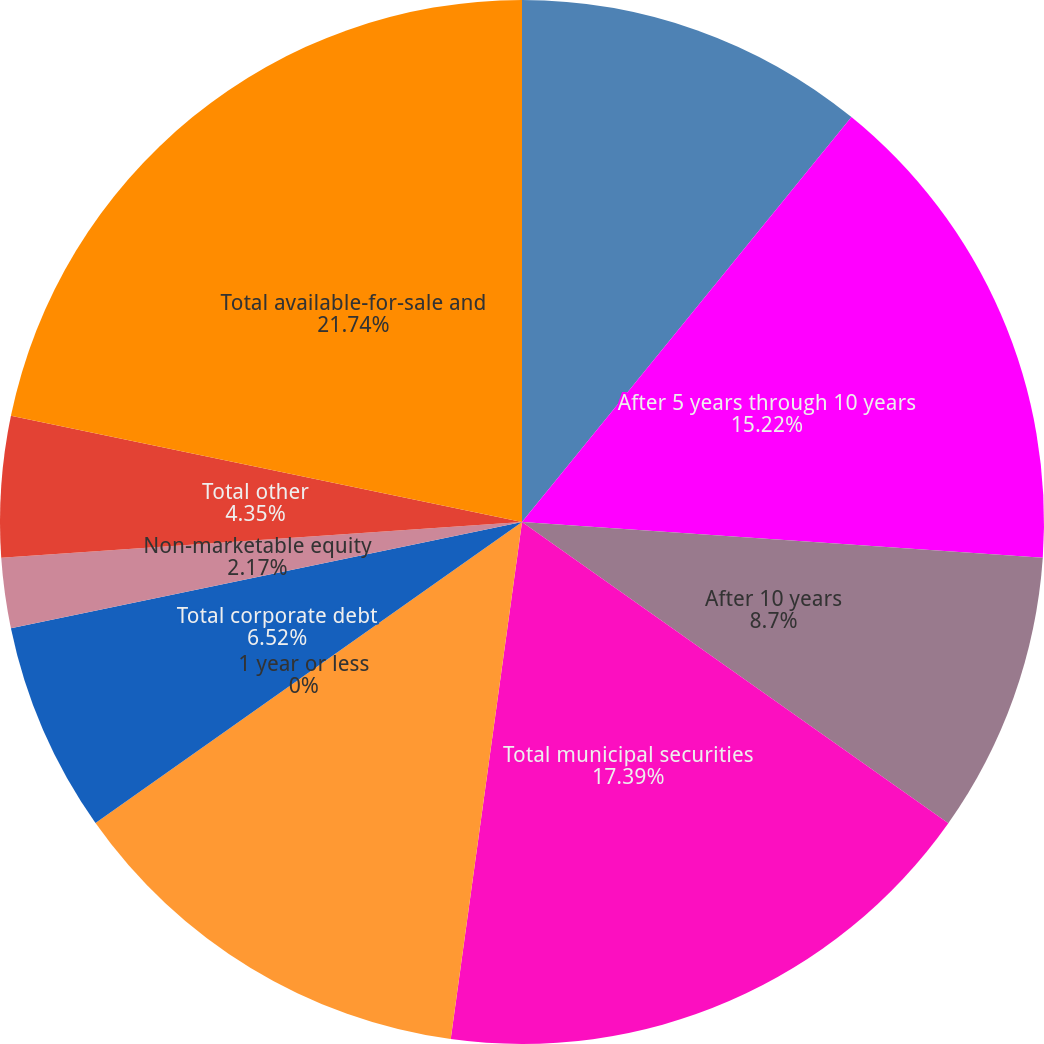Convert chart to OTSL. <chart><loc_0><loc_0><loc_500><loc_500><pie_chart><fcel>After 1 year through 5 years<fcel>After 5 years through 10 years<fcel>After 10 years<fcel>Total municipal securities<fcel>Total asset-backed securities<fcel>1 year or less<fcel>Total corporate debt<fcel>Non-marketable equity<fcel>Total other<fcel>Total available-for-sale and<nl><fcel>10.87%<fcel>15.22%<fcel>8.7%<fcel>17.39%<fcel>13.04%<fcel>0.0%<fcel>6.52%<fcel>2.17%<fcel>4.35%<fcel>21.74%<nl></chart> 